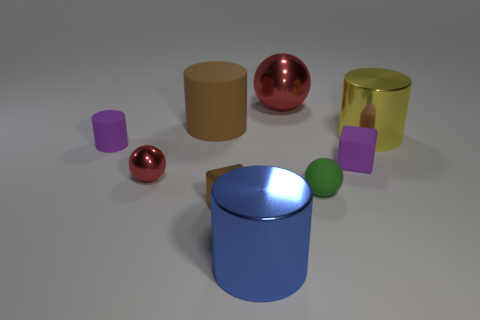Subtract all tiny purple cylinders. How many cylinders are left? 3 Subtract 1 cylinders. How many cylinders are left? 3 Add 1 small metallic spheres. How many objects exist? 10 Subtract all yellow cylinders. How many cylinders are left? 3 Subtract all spheres. How many objects are left? 6 Subtract all green cylinders. How many red balls are left? 2 Subtract all gray spheres. Subtract all blue cylinders. How many spheres are left? 3 Subtract 0 gray cylinders. How many objects are left? 9 Subtract all big red shiny objects. Subtract all small purple shiny balls. How many objects are left? 8 Add 7 blue objects. How many blue objects are left? 8 